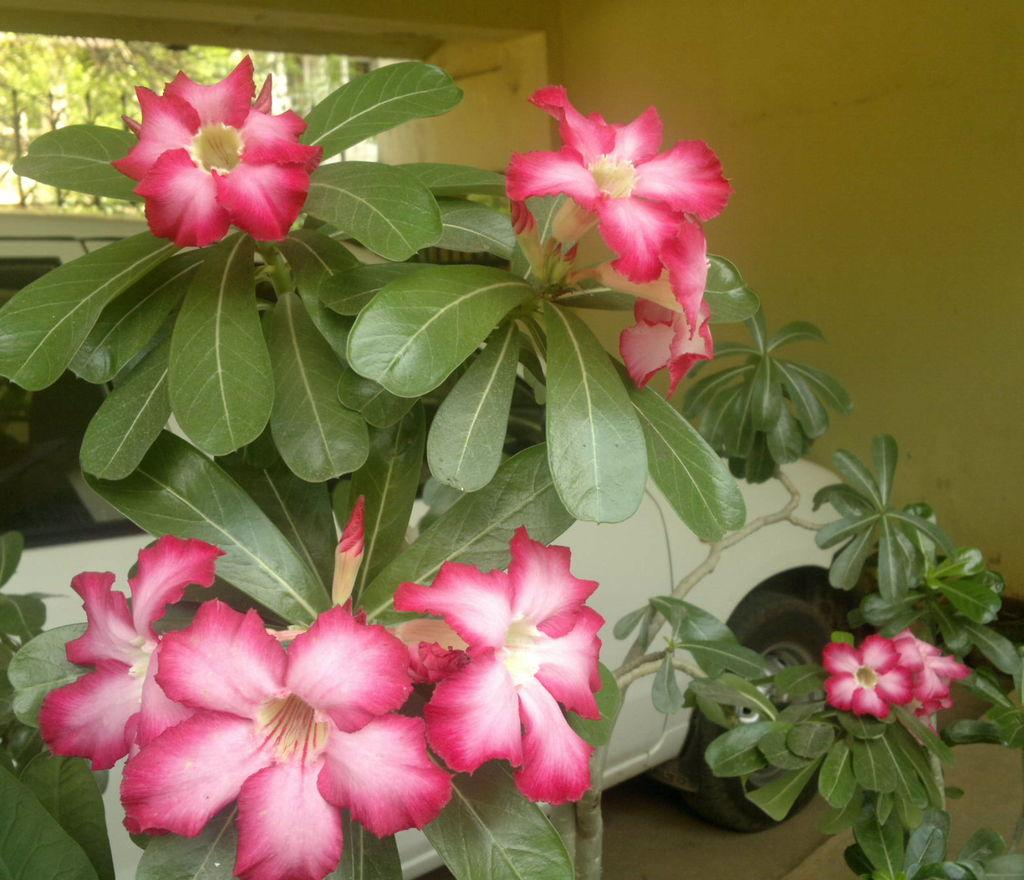What type of plant is visible in the image? There is a plant with flowers and leaves in the image. What is located behind the plant? There is a vehicle, a wall, a gate, and trees behind the plant. Can you describe the wall behind the plant? The wall is visible behind the plant. What type of trees can be seen behind the plant? Trees are visible behind the plant. How many girls are smashing bikes in the image? There are no girls or bikes present in the image. 